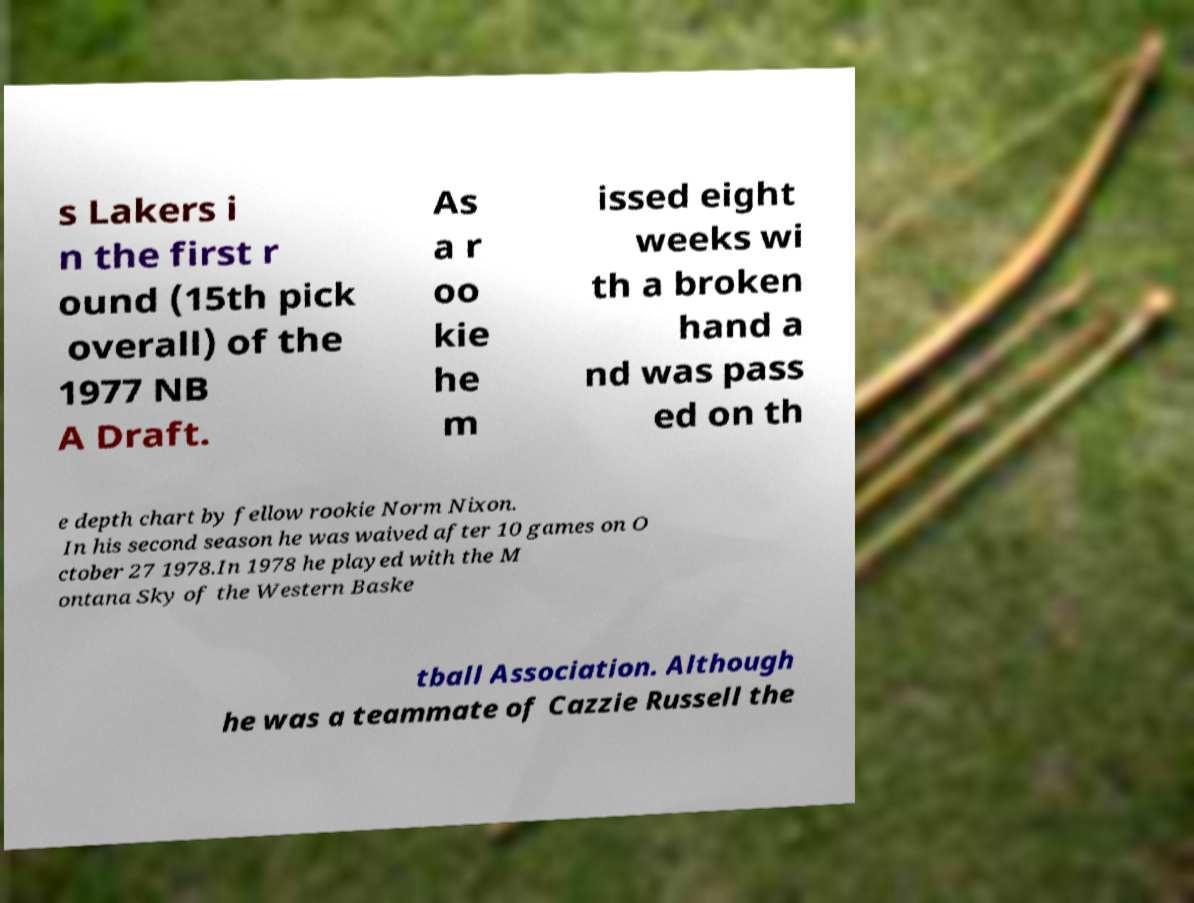Can you accurately transcribe the text from the provided image for me? s Lakers i n the first r ound (15th pick overall) of the 1977 NB A Draft. As a r oo kie he m issed eight weeks wi th a broken hand a nd was pass ed on th e depth chart by fellow rookie Norm Nixon. In his second season he was waived after 10 games on O ctober 27 1978.In 1978 he played with the M ontana Sky of the Western Baske tball Association. Although he was a teammate of Cazzie Russell the 